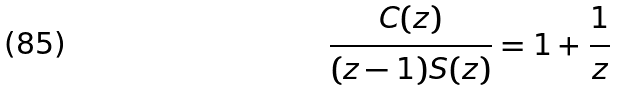<formula> <loc_0><loc_0><loc_500><loc_500>\frac { C ( z ) } { ( z - 1 ) S ( z ) } = 1 + \frac { 1 } { z }</formula> 